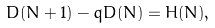<formula> <loc_0><loc_0><loc_500><loc_500>D ( N + 1 ) - q D ( N ) = H ( N ) ,</formula> 